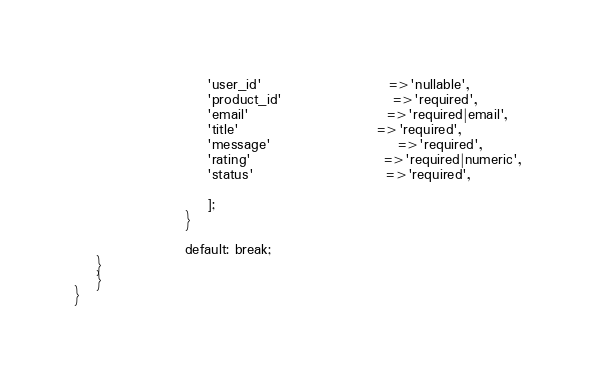Convert code to text. <code><loc_0><loc_0><loc_500><loc_500><_PHP_>                        'user_id'                       =>'nullable',
                        'product_id'                    =>'required',
                        'email'                         =>'required|email',
                        'title'                         =>'required',
                        'message'                       =>'required',
                        'rating'                        =>'required|numeric',
                        'status'                        =>'required',

                        ];
                    }

                    default: break;
    }
    }   
}
</code> 